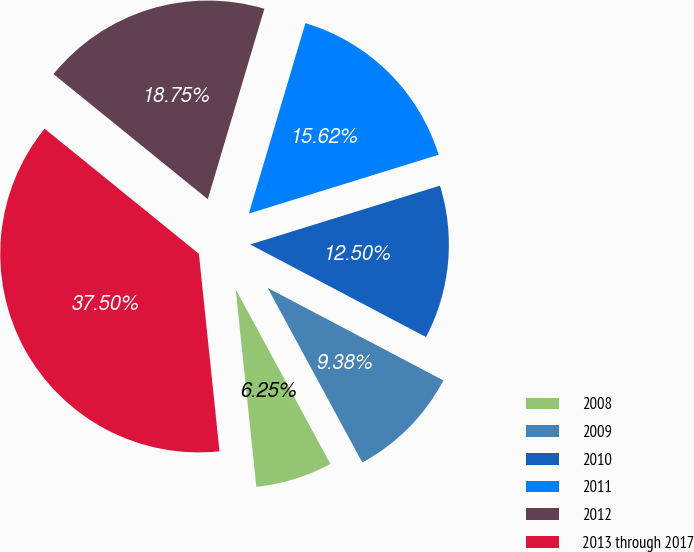<chart> <loc_0><loc_0><loc_500><loc_500><pie_chart><fcel>2008<fcel>2009<fcel>2010<fcel>2011<fcel>2012<fcel>2013 through 2017<nl><fcel>6.25%<fcel>9.38%<fcel>12.5%<fcel>15.62%<fcel>18.75%<fcel>37.5%<nl></chart> 